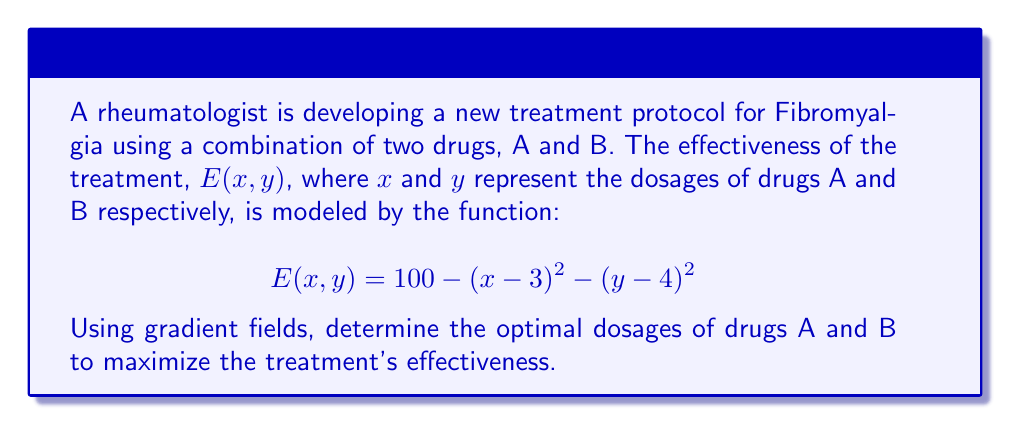Provide a solution to this math problem. To find the optimal dosages, we need to determine the maximum point of the function E(x,y). This can be done using gradient fields:

1. Calculate the gradient of E(x,y):
   $$\nabla E = \left(\frac{\partial E}{\partial x}, \frac{\partial E}{\partial y}\right)$$
   $$\frac{\partial E}{\partial x} = -2(x-3)$$
   $$\frac{\partial E}{\partial y} = -2(y-4)$$
   $$\nabla E = (-2(x-3), -2(y-4))$$

2. At the maximum point, the gradient will be zero:
   $$\nabla E = (0, 0)$$

3. Solve the system of equations:
   $$-2(x-3) = 0$$
   $$-2(y-4) = 0$$

4. Solving these equations:
   $$x-3 = 0 \implies x = 3$$
   $$y-4 = 0 \implies y = 4$$

5. Therefore, the optimal dosages are:
   Drug A: 3 units
   Drug B: 4 units

6. Verify by calculating the maximum effectiveness:
   $$E(3,4) = 100 - (3-3)^2 - (4-4)^2 = 100$$

This confirms that (3,4) is indeed the maximum point, giving the highest effectiveness of 100.
Answer: Drug A: 3 units, Drug B: 4 units 